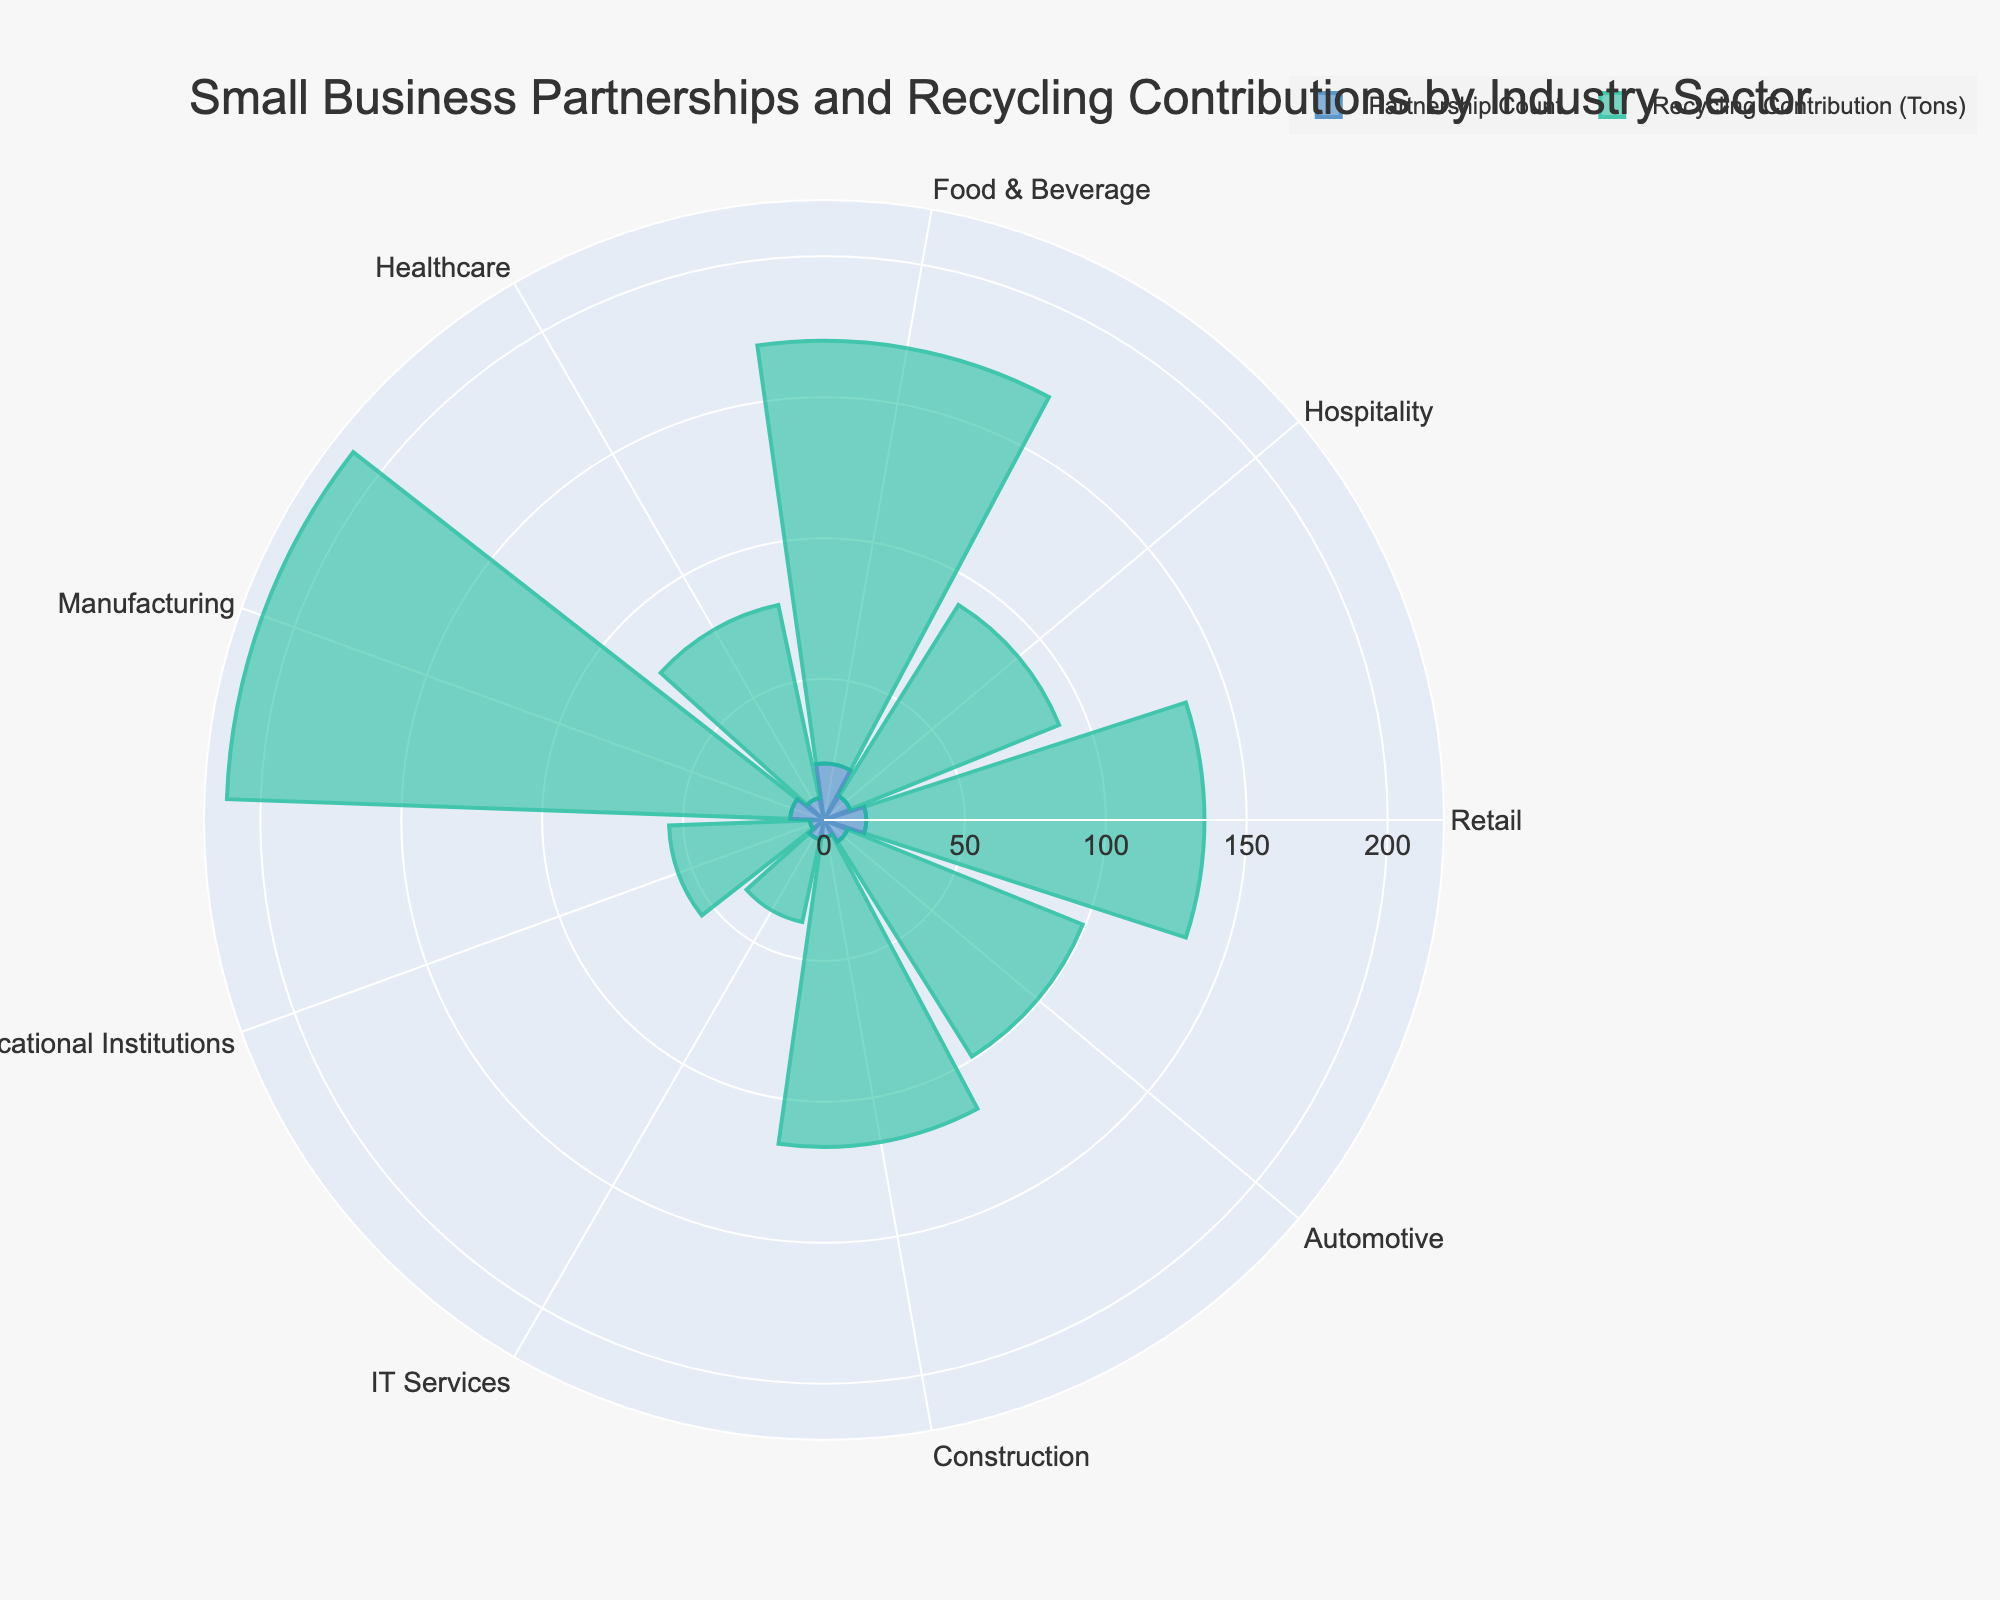Which industry sector has the highest partnership count? By observing the length of the bars in the "Partnership Count" trace, the Food & Beverage sector has the highest count.
Answer: Food & Beverage Which industry sector has the lowest recycling contribution? By looking at the height of the bars in the "Recycling Contribution (Tons)" trace, IT Services has the lowest contribution.
Answer: IT Services What is the difference in recycling contribution between the Manufacturing sector and the Healthcare sector? Manufacturing contributes 200 tons and Healthcare contributes 70 tons. The difference is 200 - 70 = 130 tons.
Answer: 130 tons Which sector has a higher recycling contribution, Retail or Automotive? By comparing the bars in the "Recycling Contribution (Tons)" trace, Automotive has a higher contribution (90 tons) than Retail (120 tons).
Answer: Retail How many sectors have a partnership count greater than 10? By counting the sectors with bars taller than 10 in the "Partnership Count" trace, the sectors are Retail, Food & Beverage, and Manufacturing. This gives us 3 sectors.
Answer: 3 sectors Is the recycling contribution of the Construction sector greater than the partnership count in the Retail sector? The Construction sector's recycling contribution is 110 tons which is less than the Retail sector's partnership count of 15.
Answer: No Which sector contributes the most to recycling, and how much do they contribute? By identifying the longest bar in the "Recycling Contribution (Tons)" trace, the Manufacturing sector contributes the most at 200 tons.
Answer: Manufacturing, 200 tons What are the total partnerships for the Hospitality and Educational Institutions sectors combined? The Hospitality sector has 10 partnerships and Educational Institutions have 5, combining them results in 10 + 5 = 15 partnerships.
Answer: 15 partnerships What is the average recycling contribution across all sectors? First sum all contributions: 120 + 80 + 150 + 70 + 200 + 50 + 30 + 110 + 90 = 900 tons. Divide by the number of sectors, which is 9: 900 / 9 = 100 tons.
Answer: 100 tons 